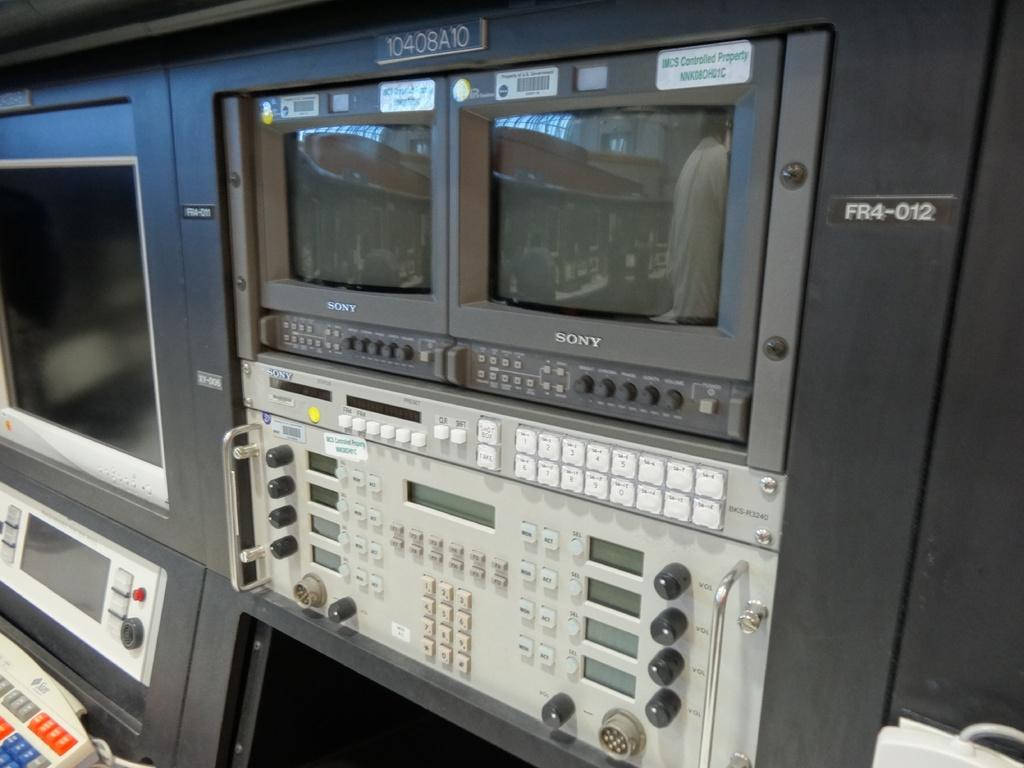Provide a one-sentence caption for the provided image. Two Sony monitors are situated above a computer panel. 